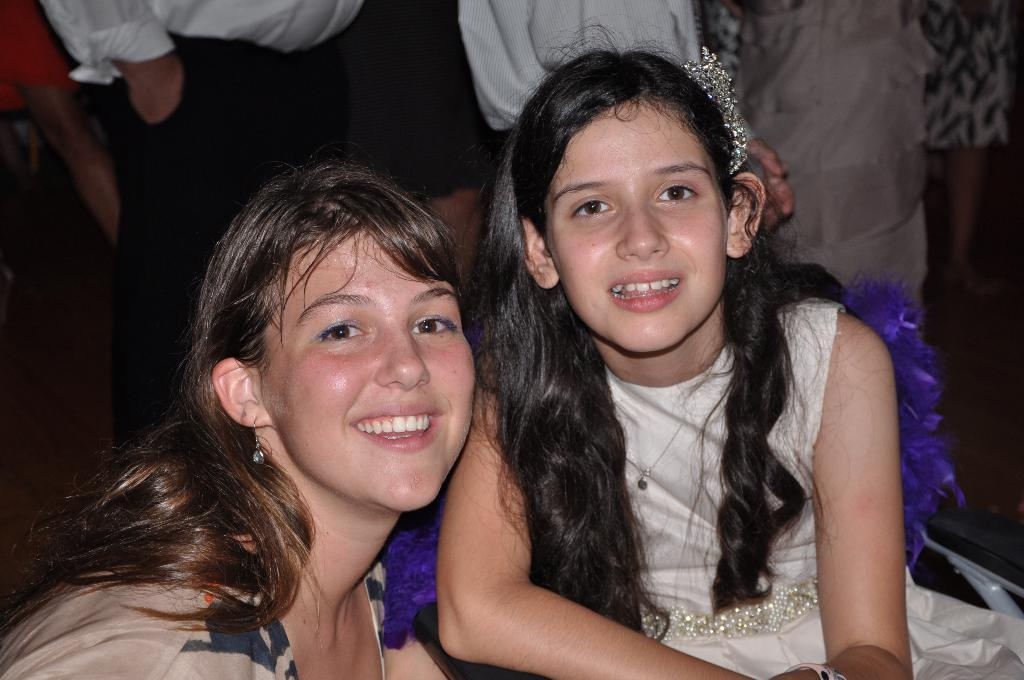Who are the main subjects in the image? There is a lady and a girl in the image. What are the expressions on their faces? Both the lady and the girl are smiling. Are there any other people visible in the image? Yes, there are people standing in the background of the image. What type of animal can be seen interacting with the lady and the girl in the image? There is no animal present in the image; it only features the lady, the girl, and people in the background. What type of growth or loss is depicted in the image? The image does not depict any growth or loss; it simply shows the lady and the girl smiling with people in the background. 